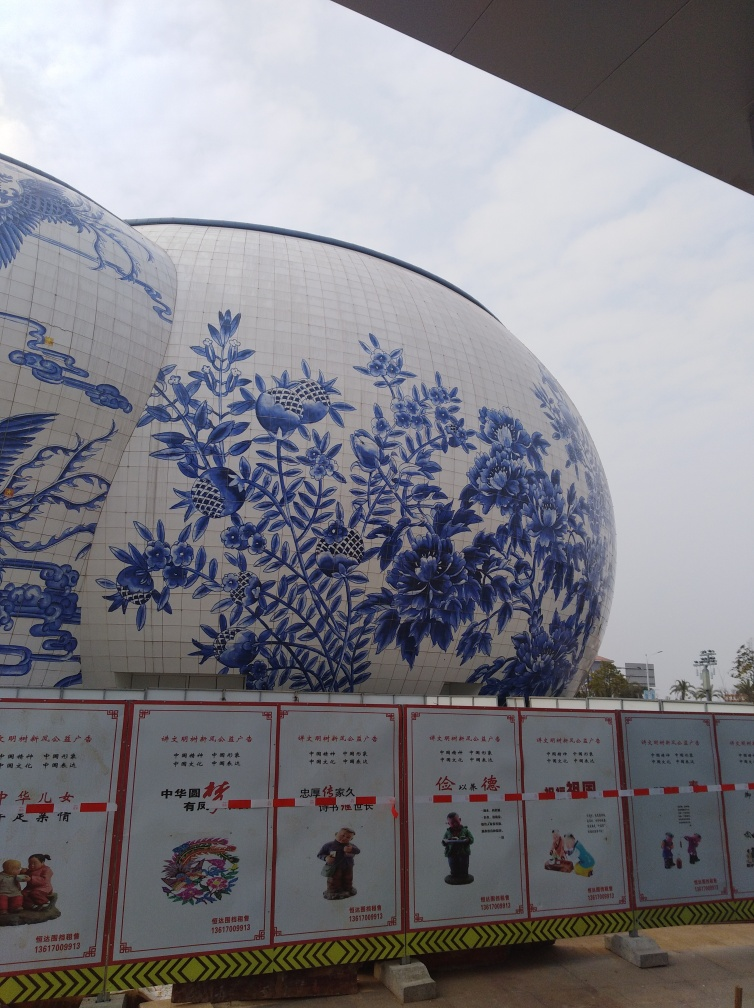What architectural style or influence does the building in the image exhibit? The building seems to showcase an aesthetic reminiscent of traditional Chinese blue and white porcelain, known for its floral designs and fauna motifs. The spherical form is modern in architecture, creating a fusion of historic art with contemporary design. 